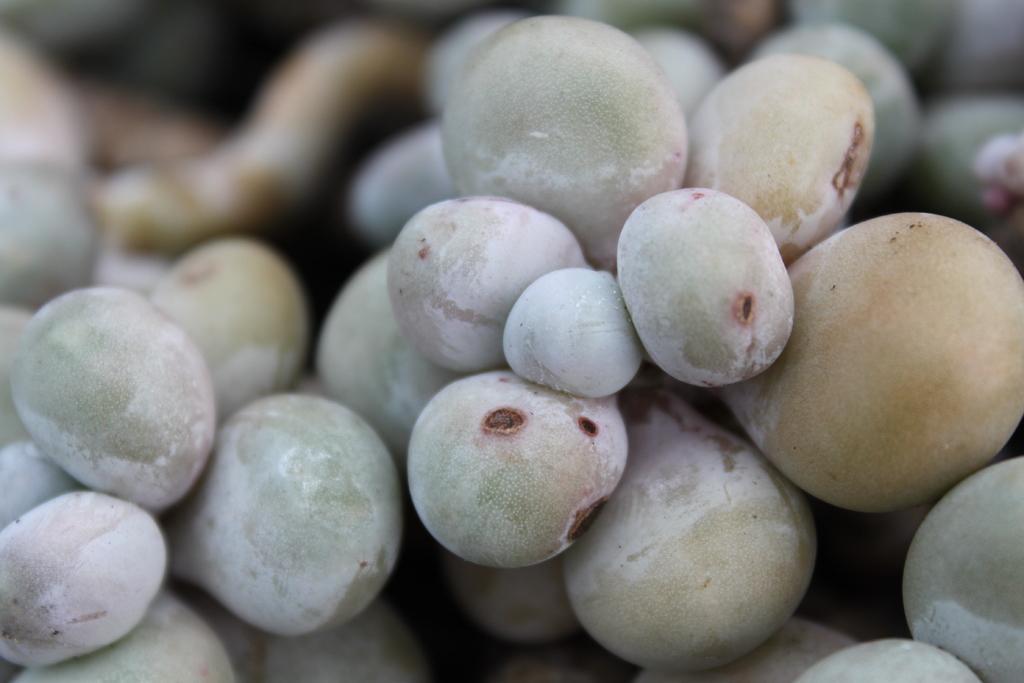Can you describe this image briefly? In this image I can see fruits, they are in cream, white and lite green color and I can see blurred background. 